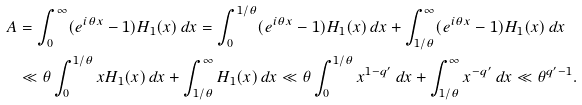Convert formula to latex. <formula><loc_0><loc_0><loc_500><loc_500>A & = \int _ { 0 } ^ { \infty } ( e ^ { i \theta x } - 1 ) H _ { 1 } ( x ) \, d x = \int _ { 0 } ^ { 1 / \theta } ( e ^ { i \theta x } - 1 ) H _ { 1 } ( x ) \, d x + \int _ { 1 / \theta } ^ { \infty } ( e ^ { i \theta x } - 1 ) H _ { 1 } ( x ) \, d x \\ & \ll \theta \int _ { 0 } ^ { 1 / \theta } x H _ { 1 } ( x ) \, d x + \int _ { 1 / \theta } ^ { \infty } H _ { 1 } ( x ) \, d x \ll \theta \int _ { 0 } ^ { 1 / \theta } x ^ { 1 - q ^ { \prime } } \, d x + \int _ { 1 / \theta } ^ { \infty } x ^ { - q ^ { \prime } } \, d x \ll \theta ^ { q ^ { \prime } - 1 } .</formula> 